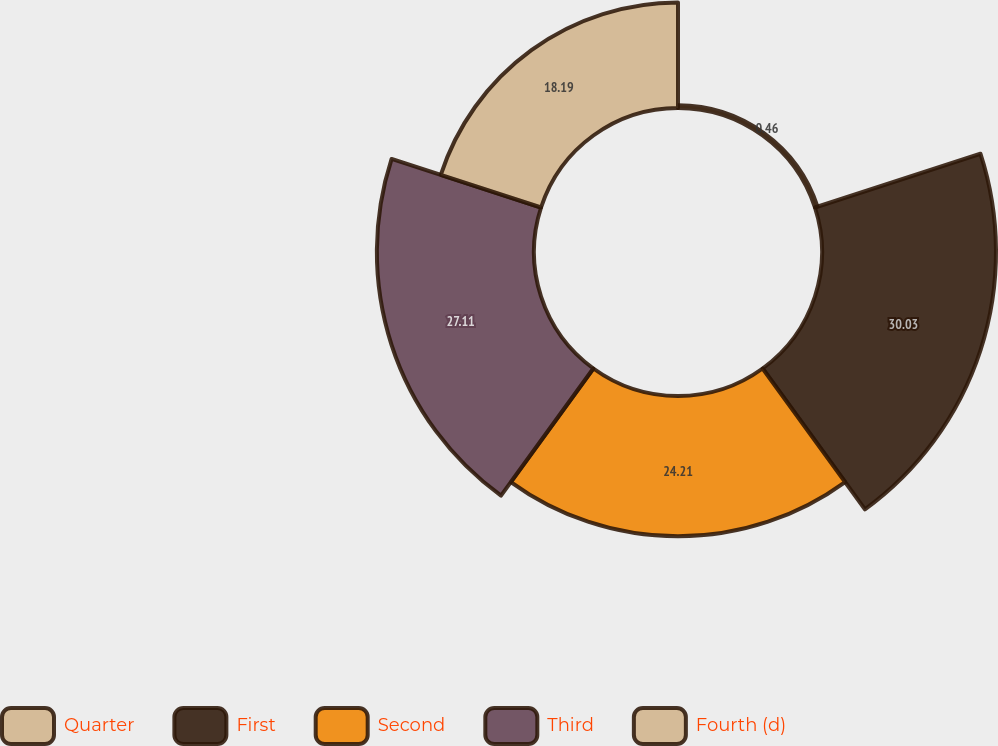Convert chart. <chart><loc_0><loc_0><loc_500><loc_500><pie_chart><fcel>Quarter<fcel>First<fcel>Second<fcel>Third<fcel>Fourth (d)<nl><fcel>0.46%<fcel>30.02%<fcel>24.21%<fcel>27.11%<fcel>18.19%<nl></chart> 